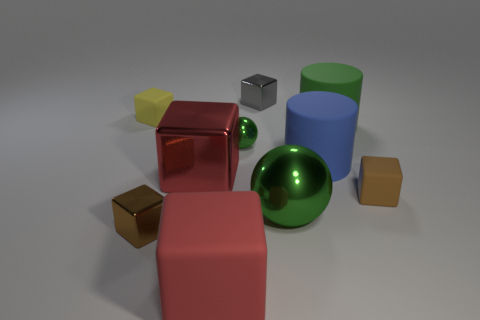There is a big metallic block; is its color the same as the rubber block that is behind the blue rubber object?
Offer a very short reply. No. There is a small shiny block that is to the right of the tiny green shiny sphere; how many big green cylinders are behind it?
Keep it short and to the point. 0. There is a shiny object that is both in front of the tiny green metal object and on the right side of the big red metal thing; what is its size?
Offer a terse response. Large. Are there any cyan blocks that have the same size as the yellow rubber object?
Your answer should be compact. No. Are there more big metal cubes that are behind the blue thing than small green balls that are behind the small yellow thing?
Ensure brevity in your answer.  No. Do the small green thing and the block behind the yellow matte cube have the same material?
Keep it short and to the point. Yes. There is a rubber cylinder in front of the big rubber cylinder that is right of the big blue object; how many small brown rubber cubes are behind it?
Your response must be concise. 0. There is a large green shiny thing; is it the same shape as the green shiny thing behind the blue rubber cylinder?
Provide a succinct answer. Yes. What color is the rubber cube that is both to the left of the tiny gray metallic object and in front of the yellow rubber object?
Keep it short and to the point. Red. The cube that is on the left side of the small metal object that is on the left side of the large red thing behind the big red rubber block is made of what material?
Your response must be concise. Rubber. 